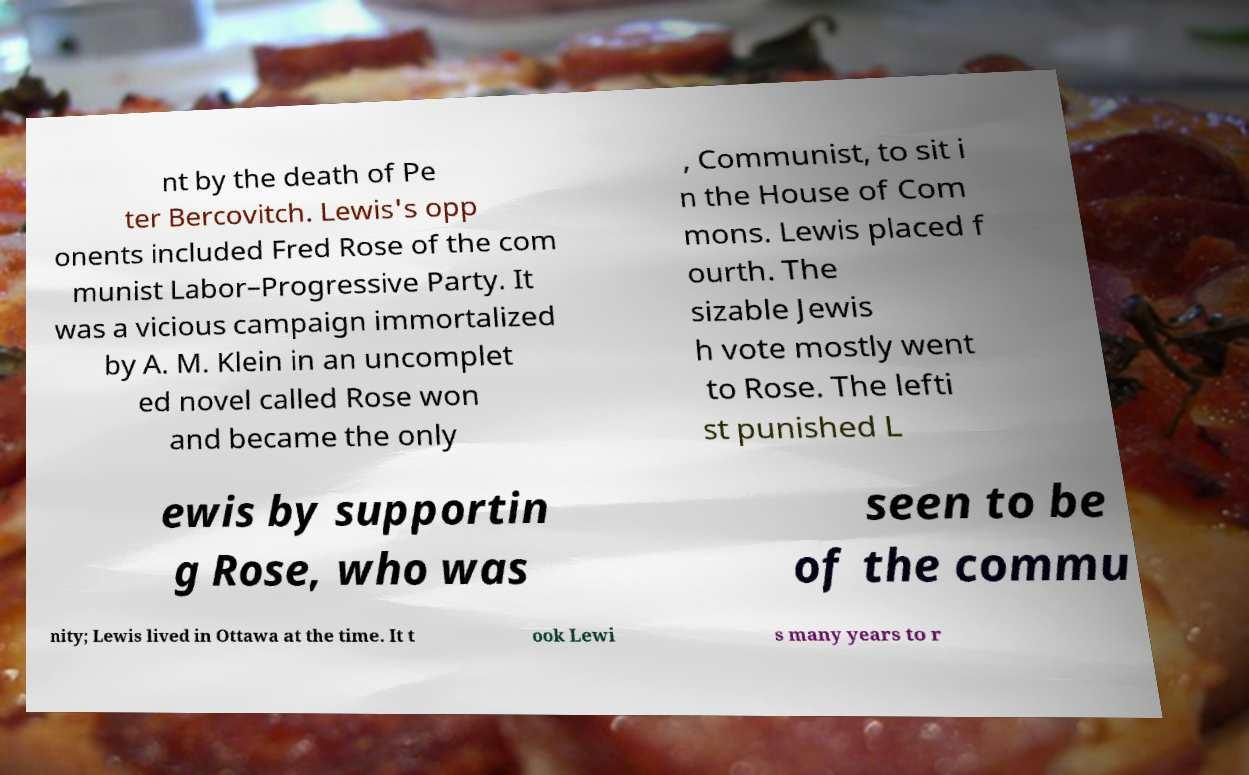Can you read and provide the text displayed in the image?This photo seems to have some interesting text. Can you extract and type it out for me? nt by the death of Pe ter Bercovitch. Lewis's opp onents included Fred Rose of the com munist Labor–Progressive Party. It was a vicious campaign immortalized by A. M. Klein in an uncomplet ed novel called Rose won and became the only , Communist, to sit i n the House of Com mons. Lewis placed f ourth. The sizable Jewis h vote mostly went to Rose. The lefti st punished L ewis by supportin g Rose, who was seen to be of the commu nity; Lewis lived in Ottawa at the time. It t ook Lewi s many years to r 